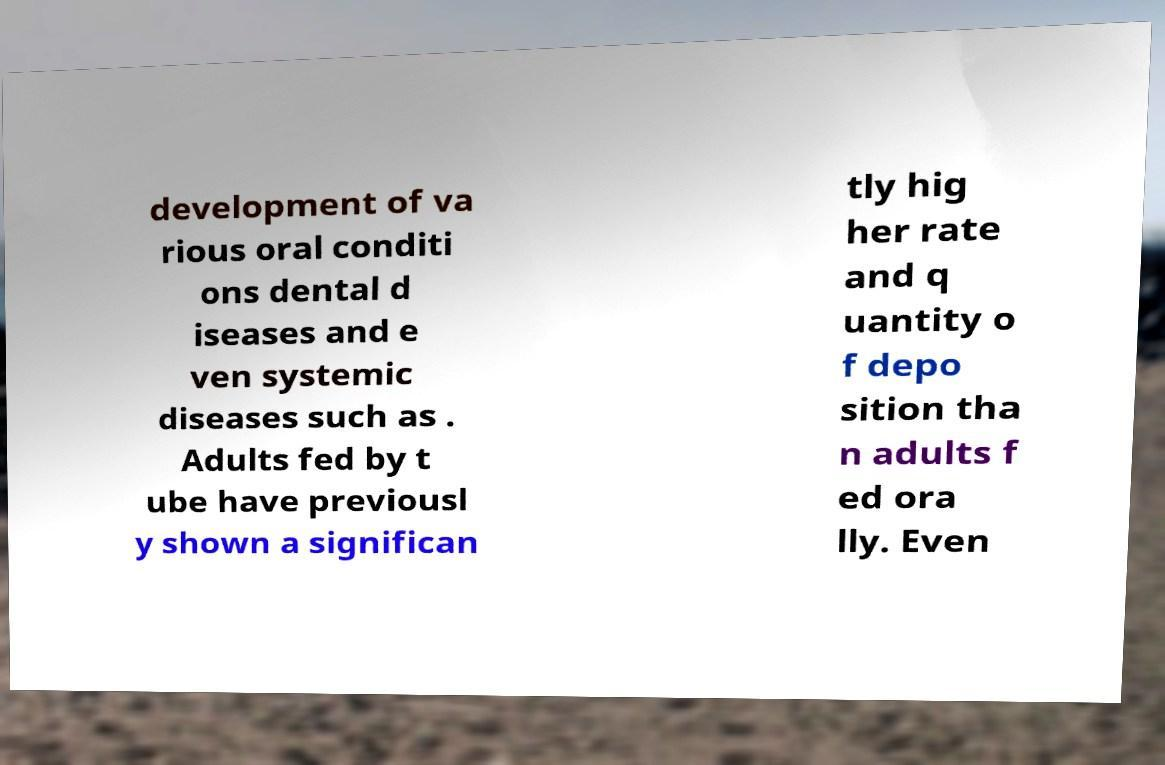What messages or text are displayed in this image? I need them in a readable, typed format. development of va rious oral conditi ons dental d iseases and e ven systemic diseases such as . Adults fed by t ube have previousl y shown a significan tly hig her rate and q uantity o f depo sition tha n adults f ed ora lly. Even 